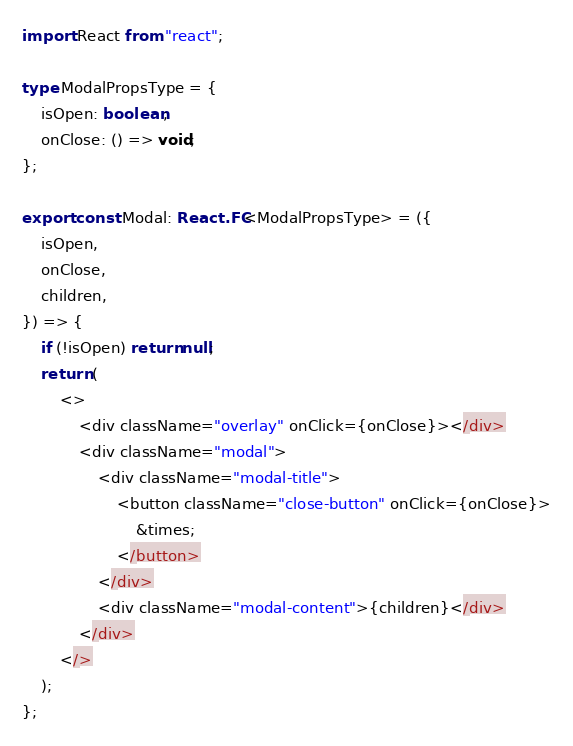<code> <loc_0><loc_0><loc_500><loc_500><_TypeScript_>import React from "react";

type ModalPropsType = {
    isOpen: boolean;
    onClose: () => void;
};

export const Modal: React.FC<ModalPropsType> = ({
    isOpen,
    onClose,
    children,
}) => {
    if (!isOpen) return null;
    return (
        <>
            <div className="overlay" onClick={onClose}></div>
            <div className="modal">
                <div className="modal-title">
                    <button className="close-button" onClick={onClose}>
                        &times;
                    </button>
                </div>
                <div className="modal-content">{children}</div>
            </div>
        </>
    );
};
</code> 